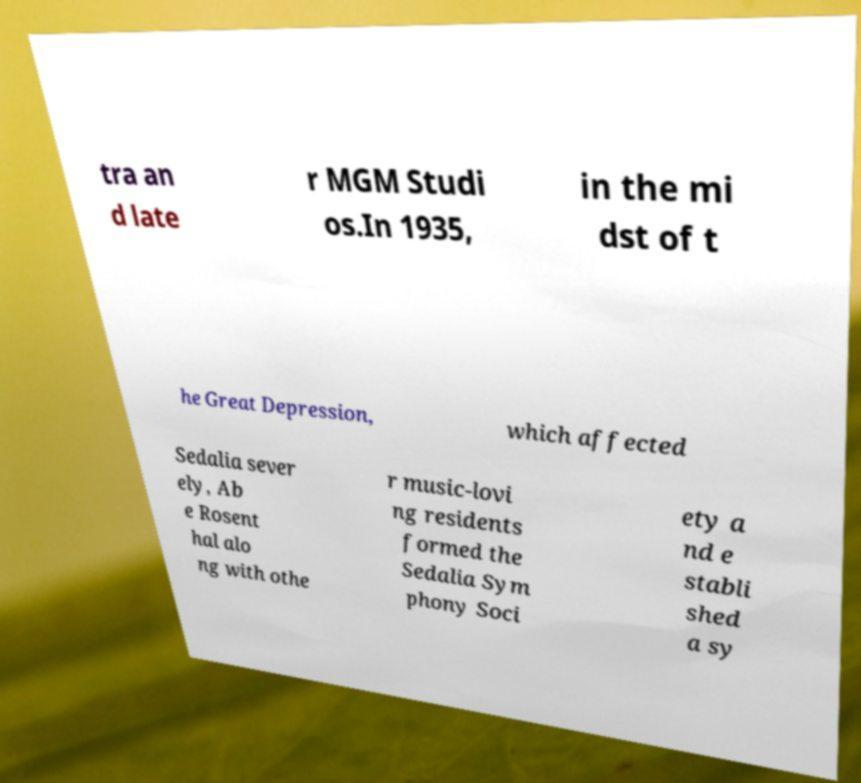Can you read and provide the text displayed in the image?This photo seems to have some interesting text. Can you extract and type it out for me? tra an d late r MGM Studi os.In 1935, in the mi dst of t he Great Depression, which affected Sedalia sever ely, Ab e Rosent hal alo ng with othe r music-lovi ng residents formed the Sedalia Sym phony Soci ety a nd e stabli shed a sy 